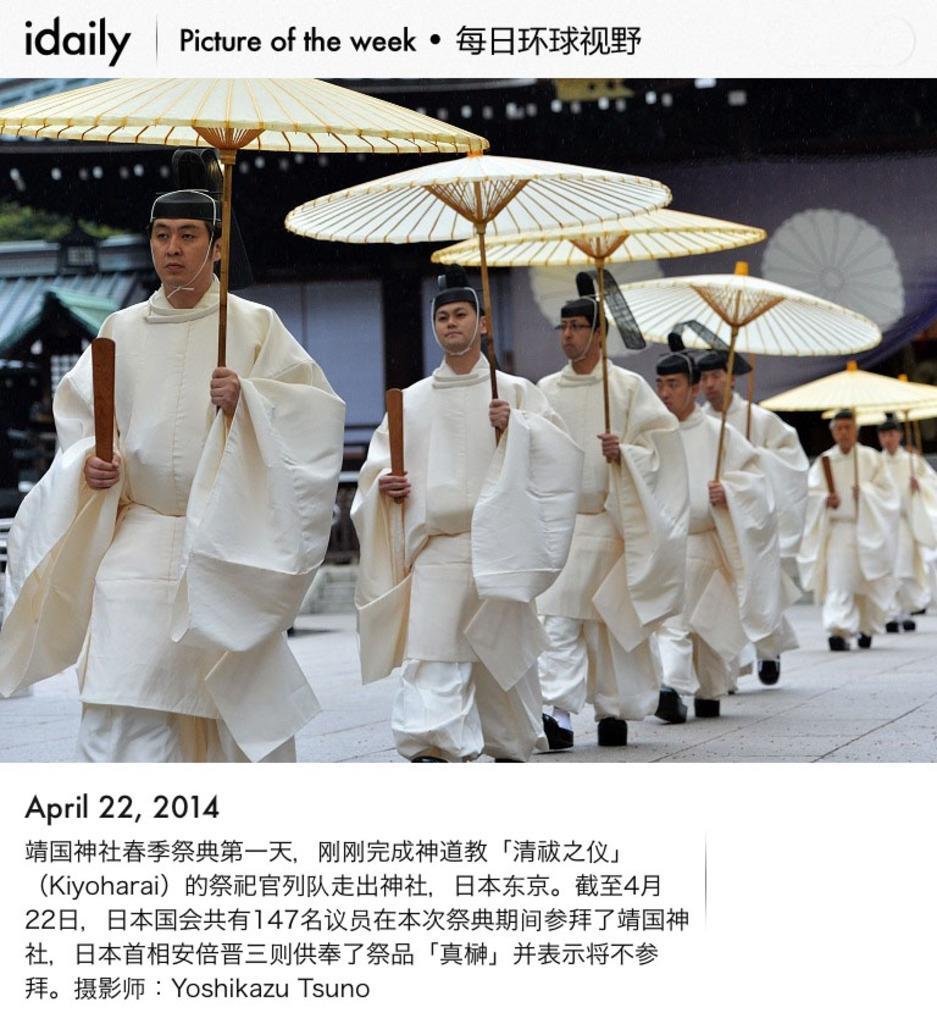Describe this image in one or two sentences. In this image I can see group of people walking and holding some object and they are wearing white color dresses and I can see few umbrellas in white color. Background I can see few buildings and trees in green color. 